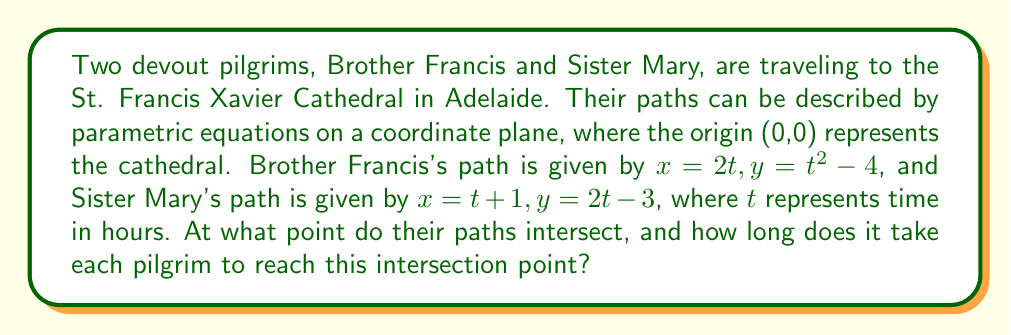Can you solve this math problem? To find the intersection point of the two pilgrims' paths, we need to equate their x and y coordinates:

1) Equate x-coordinates:
   $2t_1 = t_2 + 1$, where $t_1$ is Brother Francis's time and $t_2$ is Sister Mary's time.

2) Equate y-coordinates:
   $t_1^2 - 4 = 2t_2 - 3$

3) From the first equation, we can express $t_2$ in terms of $t_1$:
   $t_2 = 2t_1 - 1$

4) Substitute this into the second equation:
   $t_1^2 - 4 = 2(2t_1 - 1) - 3$
   $t_1^2 - 4 = 4t_1 - 2 - 3$
   $t_1^2 - 4t_1 + 1 = 0$

5) This is a quadratic equation. Solve using the quadratic formula:
   $t_1 = \frac{-b \pm \sqrt{b^2 - 4ac}}{2a}$
   $t_1 = \frac{4 \pm \sqrt{16 - 4(1)(1)}}{2(1)}$
   $t_1 = \frac{4 \pm \sqrt{12}}{2} = 2 \pm \sqrt{3}$

6) The positive solution is $t_1 = 2 + \sqrt{3}$ hours for Brother Francis.

7) For Sister Mary, $t_2 = 2t_1 - 1 = 2(2 + \sqrt{3}) - 1 = 3 + 2\sqrt{3}$ hours.

8) The intersection point can be found by substituting $t_1$ into Brother Francis's equations:
   $x = 2(2 + \sqrt{3}) = 4 + 2\sqrt{3}$
   $y = (2 + \sqrt{3})^2 - 4 = 4 + 4\sqrt{3} + 3 - 4 = 3 + 4\sqrt{3}$
Answer: The pilgrims' paths intersect at the point $(4 + 2\sqrt{3}, 3 + 4\sqrt{3})$. Brother Francis reaches this point after $2 + \sqrt{3}$ hours, while Sister Mary reaches it after $3 + 2\sqrt{3}$ hours. 